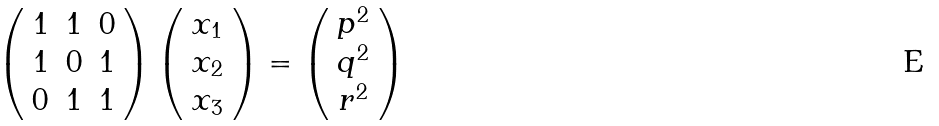<formula> <loc_0><loc_0><loc_500><loc_500>\left ( \begin{array} { c c c } 1 & 1 & 0 \\ 1 & 0 & 1 \\ 0 & 1 & 1 \end{array} \right ) \left ( \begin{array} { c } x _ { 1 } \\ x _ { 2 } \\ x _ { 3 } \end{array} \right ) = \left ( \begin{array} { c } p ^ { 2 } \\ q ^ { 2 } \\ r ^ { 2 } \end{array} \right )</formula> 